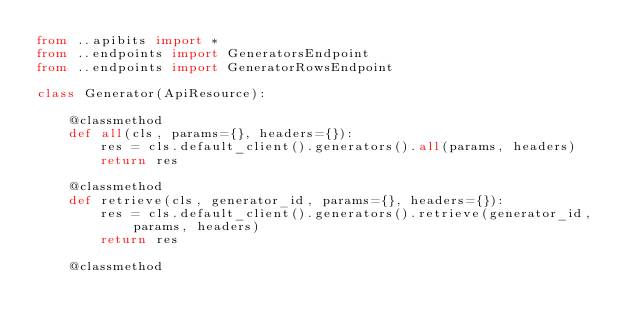<code> <loc_0><loc_0><loc_500><loc_500><_Python_>from ..apibits import *
from ..endpoints import GeneratorsEndpoint
from ..endpoints import GeneratorRowsEndpoint

class Generator(ApiResource):

    @classmethod
    def all(cls, params={}, headers={}):
        res = cls.default_client().generators().all(params, headers)
        return res

    @classmethod
    def retrieve(cls, generator_id, params={}, headers={}):
        res = cls.default_client().generators().retrieve(generator_id, params, headers)
        return res

    @classmethod</code> 